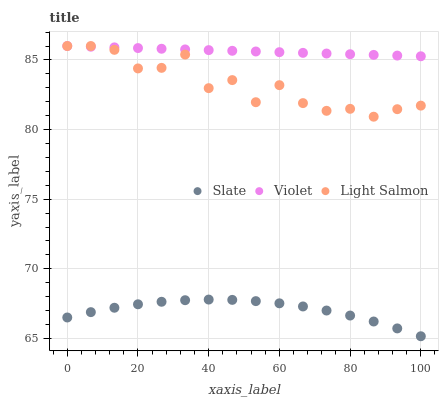Does Slate have the minimum area under the curve?
Answer yes or no. Yes. Does Violet have the maximum area under the curve?
Answer yes or no. Yes. Does Light Salmon have the minimum area under the curve?
Answer yes or no. No. Does Light Salmon have the maximum area under the curve?
Answer yes or no. No. Is Violet the smoothest?
Answer yes or no. Yes. Is Light Salmon the roughest?
Answer yes or no. Yes. Is Light Salmon the smoothest?
Answer yes or no. No. Is Violet the roughest?
Answer yes or no. No. Does Slate have the lowest value?
Answer yes or no. Yes. Does Light Salmon have the lowest value?
Answer yes or no. No. Does Violet have the highest value?
Answer yes or no. Yes. Is Slate less than Light Salmon?
Answer yes or no. Yes. Is Violet greater than Slate?
Answer yes or no. Yes. Does Violet intersect Light Salmon?
Answer yes or no. Yes. Is Violet less than Light Salmon?
Answer yes or no. No. Is Violet greater than Light Salmon?
Answer yes or no. No. Does Slate intersect Light Salmon?
Answer yes or no. No. 